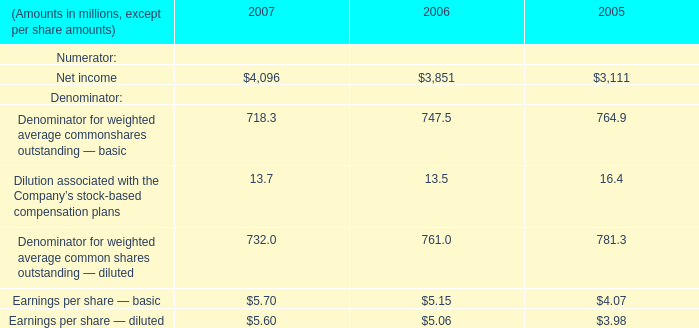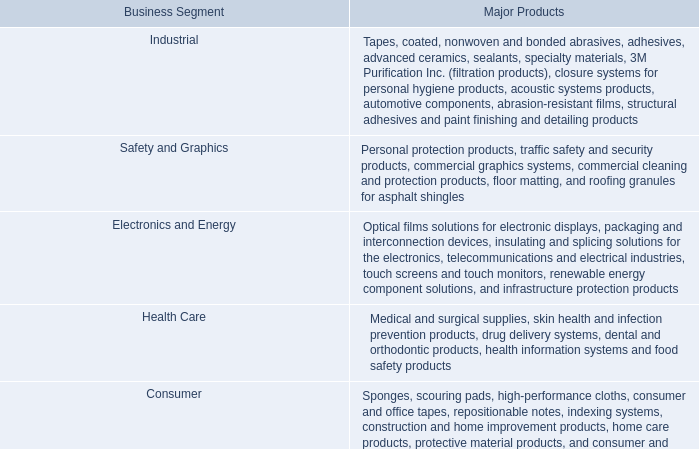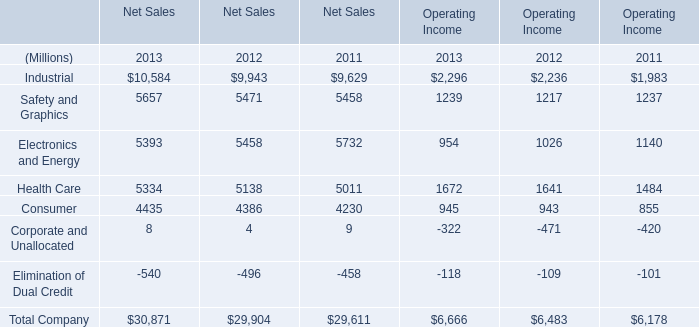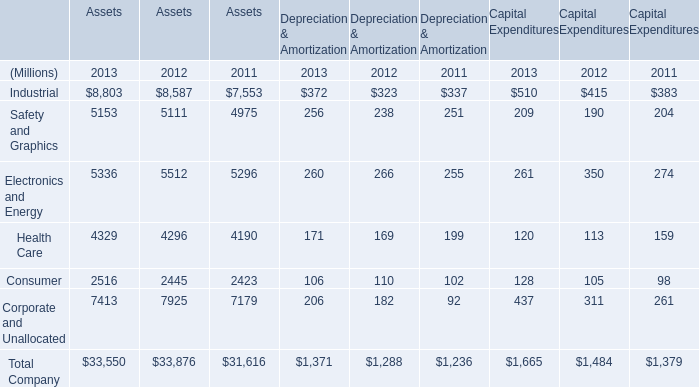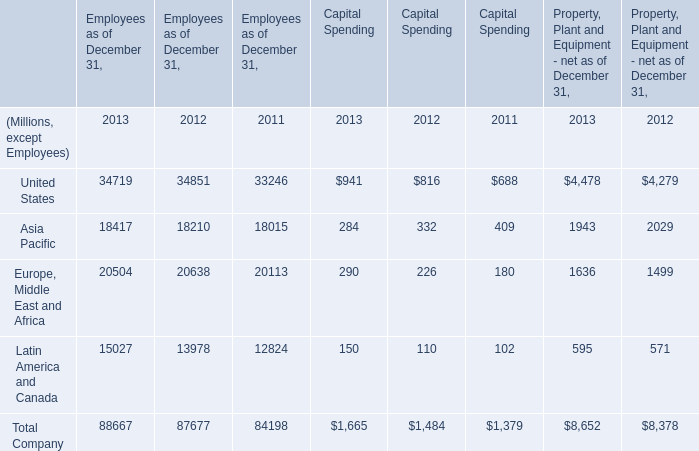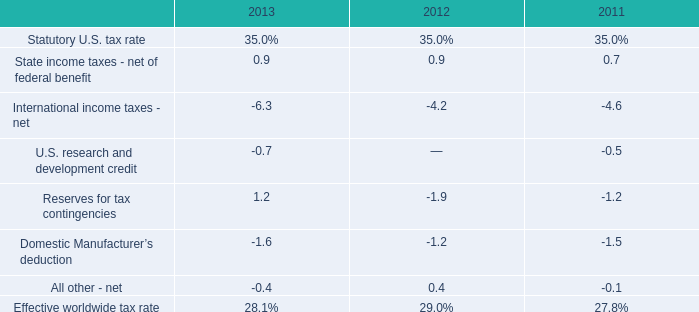What's the sum of Asia Pacific of Employees as of December 31, 2012, and Industrial of Assets 2012 ? 
Computations: (18210.0 + 8587.0)
Answer: 26797.0. 